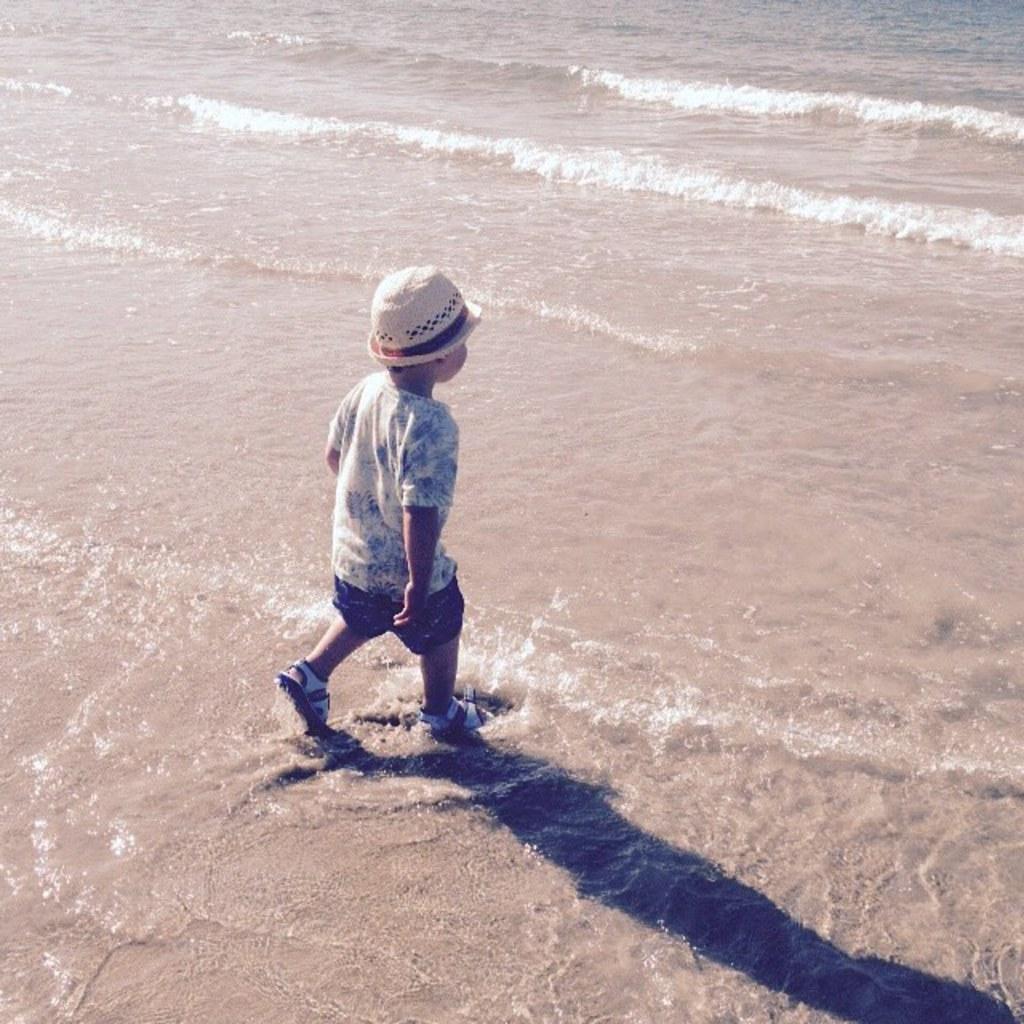Can you describe this image briefly? In this image there is a kid running on the ground. There is the water on the ground. It seems to be a beach. 